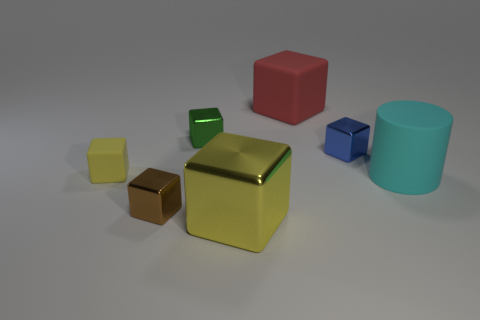What number of large cubes have the same color as the tiny rubber block?
Your answer should be compact. 1. What is the shape of the thing that is on the left side of the big shiny cube and behind the tiny blue shiny object?
Keep it short and to the point. Cube. There is a small shiny thing in front of the blue metallic object; what is its shape?
Your response must be concise. Cube. What is the size of the metallic object that is right of the large object that is on the left side of the rubber block that is right of the green block?
Give a very brief answer. Small. Do the blue thing and the yellow rubber thing have the same shape?
Provide a short and direct response. Yes. There is a rubber object that is both in front of the small blue thing and to the left of the big cyan thing; what is its size?
Offer a very short reply. Small. There is a tiny brown object that is the same shape as the red rubber thing; what is its material?
Provide a succinct answer. Metal. What is the material of the tiny block to the right of the small green cube that is to the right of the small yellow thing?
Keep it short and to the point. Metal. There is a large metal thing; is it the same shape as the yellow object that is on the left side of the small brown object?
Make the answer very short. Yes. How many shiny objects are either red objects or cyan cylinders?
Ensure brevity in your answer.  0. 